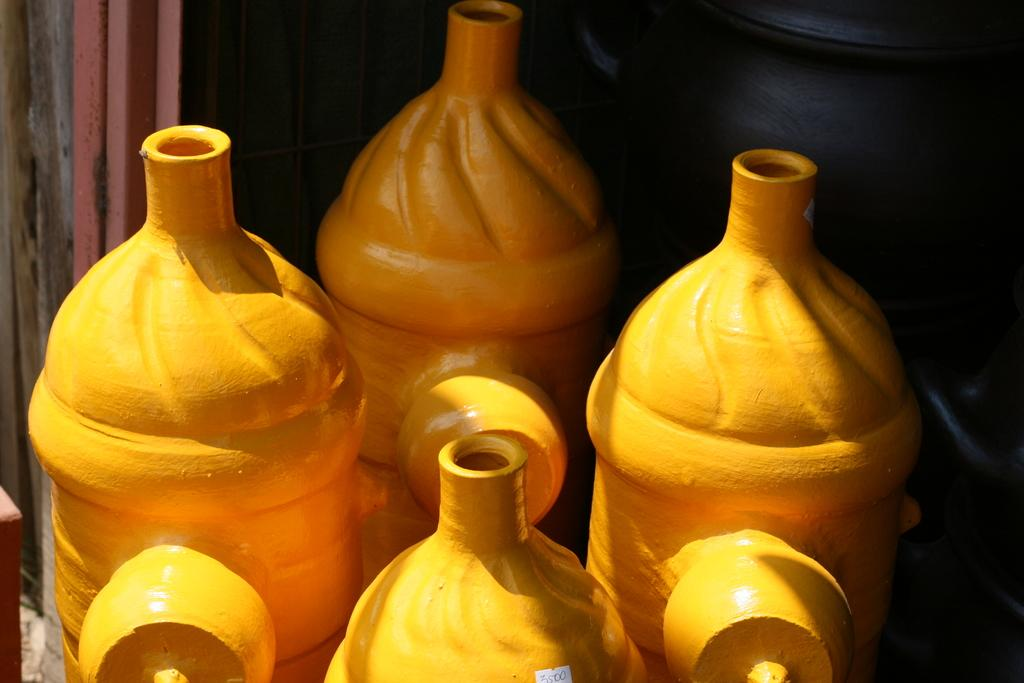What can be seen in the image? There are objects in the image. Can you describe the color of some of the objects? Some of the objects are in yellow color. What else can be observed in the image? There are other objects in the background of the image. How many people are participating in the feast in the image? There is no feast or people present in the image; it only contains objects. What type of bit is being used to eat the food in the image? There is no food or bit present in the image; it only contains objects. 